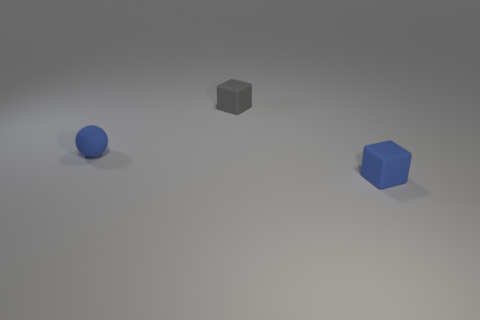Add 2 large red shiny spheres. How many objects exist? 5 Subtract all spheres. How many objects are left? 2 Add 3 big gray shiny things. How many big gray shiny things exist? 3 Subtract 0 cyan spheres. How many objects are left? 3 Subtract all balls. Subtract all large red matte spheres. How many objects are left? 2 Add 2 tiny gray matte cubes. How many tiny gray matte cubes are left? 3 